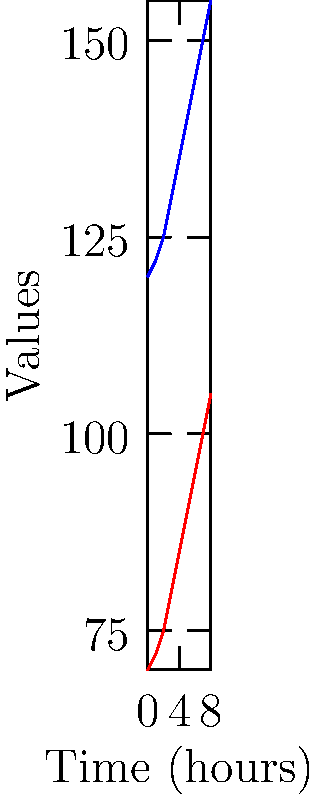Based on your extensive clinical experience, what is the most likely cause of the trend seen in this patient's vital signs over time? To interpret this trend, we need to consider several factors:

1. Both heart rate and blood pressure are steadily increasing over time.
2. The increase is gradual and consistent, not sudden or erratic.
3. The rate of increase is similar for both parameters.

Given these observations and considering common clinical scenarios:

1. Pain: Increasing pain can cause a gradual increase in both heart rate and blood pressure.
2. Anxiety: As anxiety builds up, it can lead to a similar trend in vital signs.
3. Fever: A rising temperature can cause tachycardia and an increase in blood pressure.
4. Medication wearing off: If the patient was on blood pressure or heart rate-lowering medications, their effect wearing off could cause this trend.
5. Blood loss: However, this typically causes a drop in blood pressure, which we don't see here.

Considering the gradual and consistent nature of the increase, and based on clinical experience, pain is the most likely cause. It's a common scenario where untreated or worsening pain leads to a steady increase in both heart rate and blood pressure over time.

This interpretation aligns with experience-based medicine, as it's a pattern often observed in clinical practice, particularly in post-operative or trauma patients.
Answer: Increasing pain 